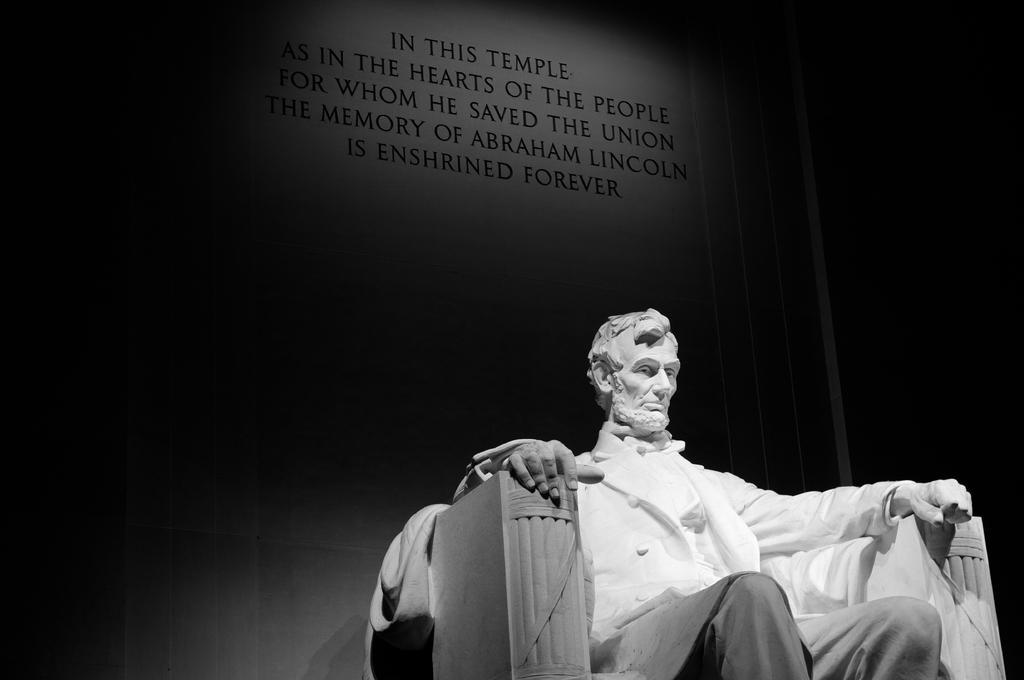In one or two sentences, can you explain what this image depicts? This is a black and white pic and we can see a statue here of a person sitting on the chair. In the background there is a text written on a platform. 